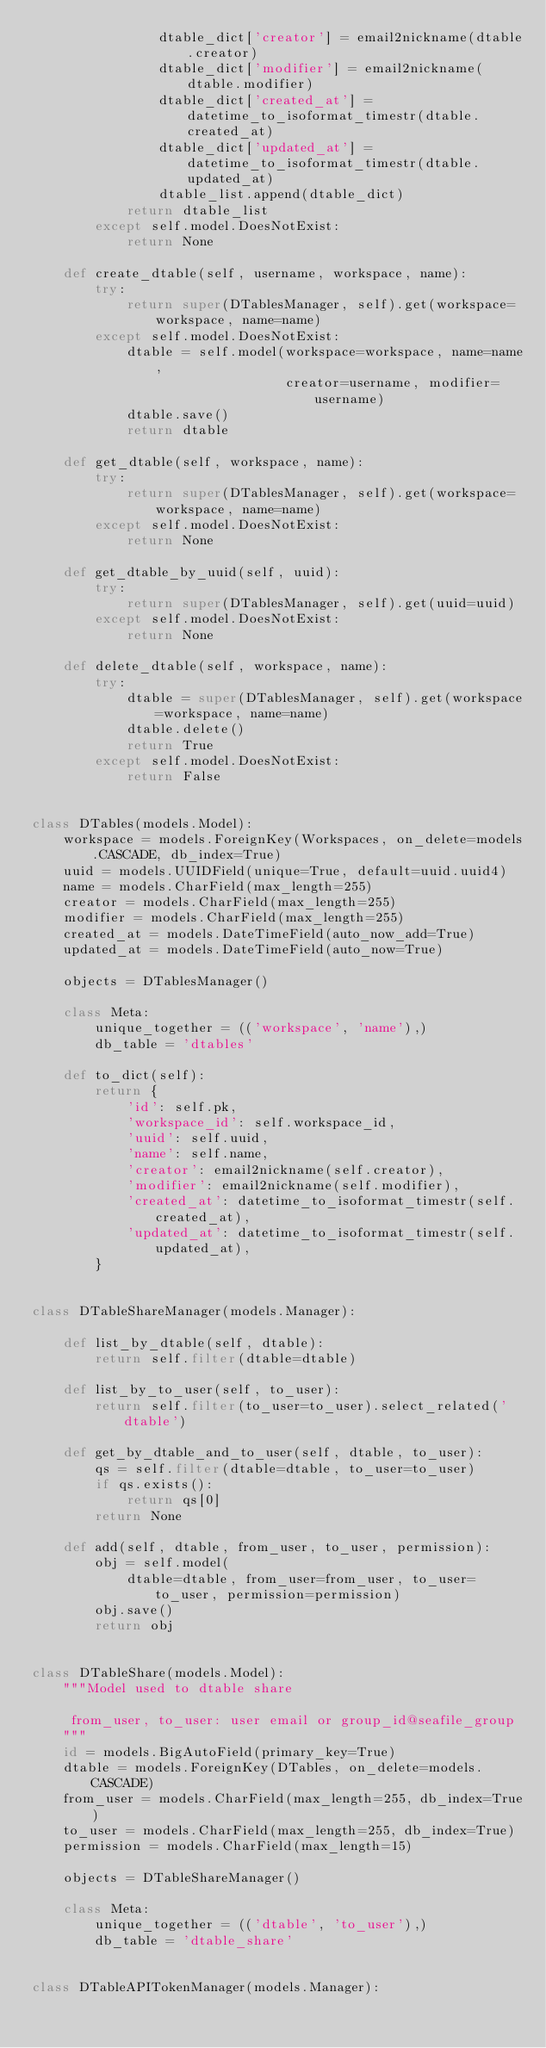<code> <loc_0><loc_0><loc_500><loc_500><_Python_>                dtable_dict['creator'] = email2nickname(dtable.creator)
                dtable_dict['modifier'] = email2nickname(dtable.modifier)
                dtable_dict['created_at'] = datetime_to_isoformat_timestr(dtable.created_at)
                dtable_dict['updated_at'] = datetime_to_isoformat_timestr(dtable.updated_at)
                dtable_list.append(dtable_dict)
            return dtable_list
        except self.model.DoesNotExist:
            return None

    def create_dtable(self, username, workspace, name):
        try:
            return super(DTablesManager, self).get(workspace=workspace, name=name)
        except self.model.DoesNotExist:
            dtable = self.model(workspace=workspace, name=name,
                                creator=username, modifier=username)
            dtable.save()
            return dtable

    def get_dtable(self, workspace, name):
        try:
            return super(DTablesManager, self).get(workspace=workspace, name=name)
        except self.model.DoesNotExist:
            return None

    def get_dtable_by_uuid(self, uuid):
        try:
            return super(DTablesManager, self).get(uuid=uuid)
        except self.model.DoesNotExist:
            return None

    def delete_dtable(self, workspace, name):
        try:
            dtable = super(DTablesManager, self).get(workspace=workspace, name=name)
            dtable.delete()
            return True
        except self.model.DoesNotExist:
            return False


class DTables(models.Model):
    workspace = models.ForeignKey(Workspaces, on_delete=models.CASCADE, db_index=True)
    uuid = models.UUIDField(unique=True, default=uuid.uuid4)
    name = models.CharField(max_length=255)
    creator = models.CharField(max_length=255)
    modifier = models.CharField(max_length=255)
    created_at = models.DateTimeField(auto_now_add=True)
    updated_at = models.DateTimeField(auto_now=True)

    objects = DTablesManager()

    class Meta:
        unique_together = (('workspace', 'name'),)
        db_table = 'dtables'

    def to_dict(self):
        return {
            'id': self.pk,
            'workspace_id': self.workspace_id,
            'uuid': self.uuid,
            'name': self.name,
            'creator': email2nickname(self.creator),
            'modifier': email2nickname(self.modifier),
            'created_at': datetime_to_isoformat_timestr(self.created_at),
            'updated_at': datetime_to_isoformat_timestr(self.updated_at),
        }


class DTableShareManager(models.Manager):

    def list_by_dtable(self, dtable):
        return self.filter(dtable=dtable)

    def list_by_to_user(self, to_user):
        return self.filter(to_user=to_user).select_related('dtable')

    def get_by_dtable_and_to_user(self, dtable, to_user):
        qs = self.filter(dtable=dtable, to_user=to_user)
        if qs.exists():
            return qs[0]
        return None

    def add(self, dtable, from_user, to_user, permission):
        obj = self.model(
            dtable=dtable, from_user=from_user, to_user=to_user, permission=permission)
        obj.save()
        return obj


class DTableShare(models.Model):
    """Model used to dtable share

     from_user, to_user: user email or group_id@seafile_group
    """
    id = models.BigAutoField(primary_key=True)
    dtable = models.ForeignKey(DTables, on_delete=models.CASCADE)
    from_user = models.CharField(max_length=255, db_index=True)
    to_user = models.CharField(max_length=255, db_index=True)
    permission = models.CharField(max_length=15)

    objects = DTableShareManager()

    class Meta:
        unique_together = (('dtable', 'to_user'),)
        db_table = 'dtable_share'


class DTableAPITokenManager(models.Manager):
</code> 